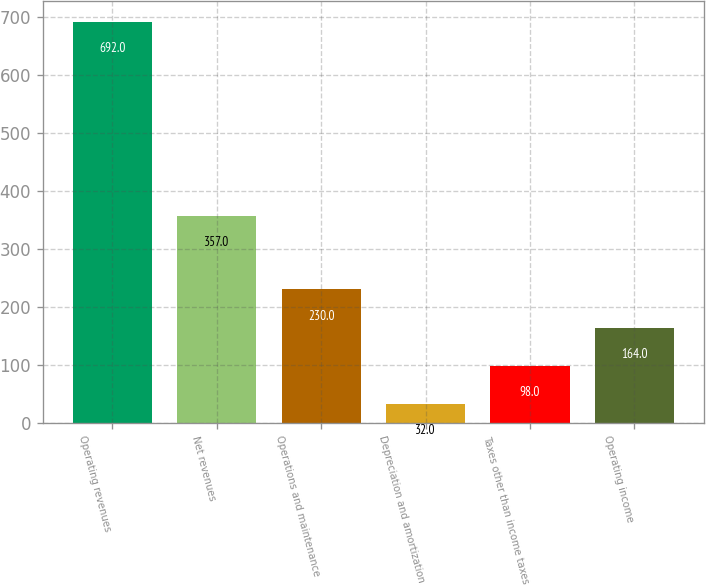Convert chart. <chart><loc_0><loc_0><loc_500><loc_500><bar_chart><fcel>Operating revenues<fcel>Net revenues<fcel>Operations and maintenance<fcel>Depreciation and amortization<fcel>Taxes other than income taxes<fcel>Operating income<nl><fcel>692<fcel>357<fcel>230<fcel>32<fcel>98<fcel>164<nl></chart> 